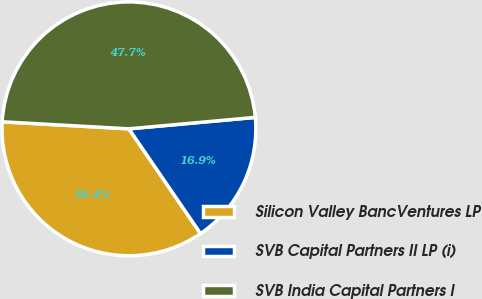Convert chart. <chart><loc_0><loc_0><loc_500><loc_500><pie_chart><fcel>Silicon Valley BancVentures LP<fcel>SVB Capital Partners II LP (i)<fcel>SVB India Capital Partners I<nl><fcel>35.43%<fcel>16.89%<fcel>47.68%<nl></chart> 